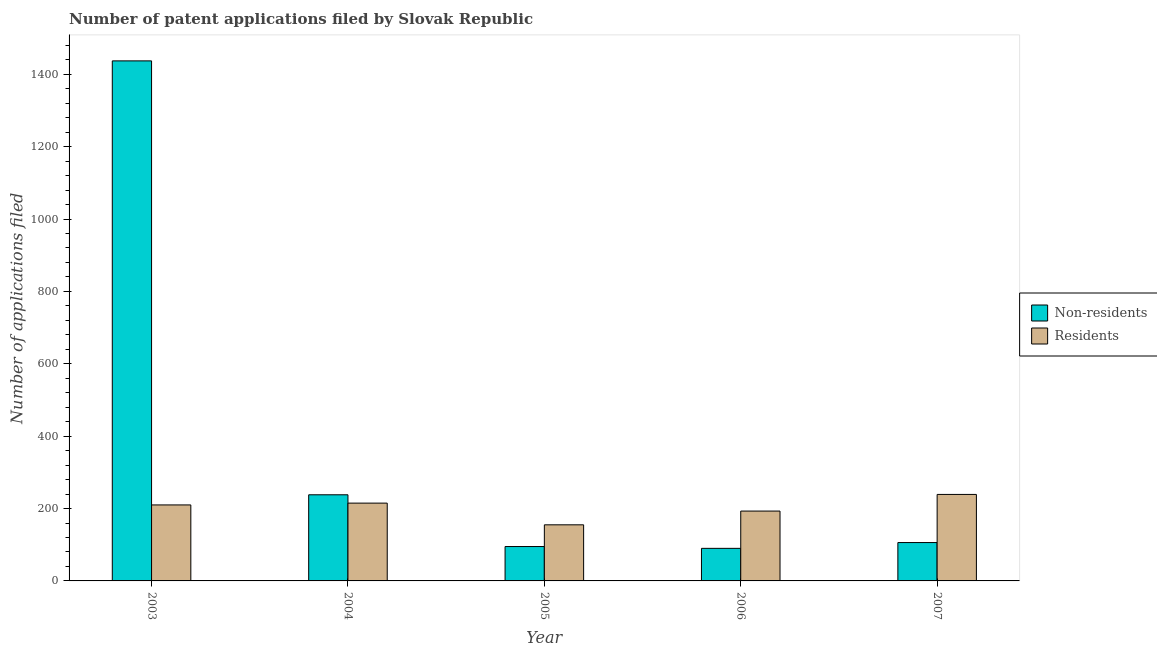How many different coloured bars are there?
Your response must be concise. 2. Are the number of bars per tick equal to the number of legend labels?
Provide a succinct answer. Yes. What is the number of patent applications by residents in 2003?
Ensure brevity in your answer.  210. Across all years, what is the maximum number of patent applications by residents?
Provide a succinct answer. 239. Across all years, what is the minimum number of patent applications by residents?
Offer a very short reply. 155. In which year was the number of patent applications by residents minimum?
Offer a very short reply. 2005. What is the total number of patent applications by non residents in the graph?
Your response must be concise. 1966. What is the difference between the number of patent applications by non residents in 2003 and that in 2006?
Keep it short and to the point. 1347. What is the difference between the number of patent applications by residents in 2004 and the number of patent applications by non residents in 2007?
Keep it short and to the point. -24. What is the average number of patent applications by residents per year?
Offer a terse response. 202.4. In the year 2006, what is the difference between the number of patent applications by non residents and number of patent applications by residents?
Ensure brevity in your answer.  0. In how many years, is the number of patent applications by residents greater than 1120?
Keep it short and to the point. 0. What is the ratio of the number of patent applications by residents in 2003 to that in 2005?
Offer a terse response. 1.35. Is the number of patent applications by non residents in 2006 less than that in 2007?
Keep it short and to the point. Yes. What is the difference between the highest and the second highest number of patent applications by residents?
Give a very brief answer. 24. What is the difference between the highest and the lowest number of patent applications by residents?
Your answer should be very brief. 84. In how many years, is the number of patent applications by residents greater than the average number of patent applications by residents taken over all years?
Your response must be concise. 3. What does the 2nd bar from the left in 2004 represents?
Your response must be concise. Residents. What does the 1st bar from the right in 2003 represents?
Your response must be concise. Residents. How many bars are there?
Offer a terse response. 10. Are all the bars in the graph horizontal?
Your answer should be compact. No. How many years are there in the graph?
Your answer should be very brief. 5. Are the values on the major ticks of Y-axis written in scientific E-notation?
Provide a short and direct response. No. How many legend labels are there?
Your response must be concise. 2. What is the title of the graph?
Keep it short and to the point. Number of patent applications filed by Slovak Republic. Does "Highest 20% of population" appear as one of the legend labels in the graph?
Your answer should be very brief. No. What is the label or title of the X-axis?
Give a very brief answer. Year. What is the label or title of the Y-axis?
Provide a short and direct response. Number of applications filed. What is the Number of applications filed in Non-residents in 2003?
Provide a succinct answer. 1437. What is the Number of applications filed of Residents in 2003?
Offer a terse response. 210. What is the Number of applications filed in Non-residents in 2004?
Offer a terse response. 238. What is the Number of applications filed in Residents in 2004?
Provide a short and direct response. 215. What is the Number of applications filed of Non-residents in 2005?
Keep it short and to the point. 95. What is the Number of applications filed in Residents in 2005?
Your response must be concise. 155. What is the Number of applications filed of Non-residents in 2006?
Your answer should be very brief. 90. What is the Number of applications filed of Residents in 2006?
Provide a short and direct response. 193. What is the Number of applications filed in Non-residents in 2007?
Offer a terse response. 106. What is the Number of applications filed in Residents in 2007?
Keep it short and to the point. 239. Across all years, what is the maximum Number of applications filed in Non-residents?
Your answer should be compact. 1437. Across all years, what is the maximum Number of applications filed of Residents?
Your response must be concise. 239. Across all years, what is the minimum Number of applications filed in Non-residents?
Provide a succinct answer. 90. Across all years, what is the minimum Number of applications filed of Residents?
Give a very brief answer. 155. What is the total Number of applications filed of Non-residents in the graph?
Give a very brief answer. 1966. What is the total Number of applications filed of Residents in the graph?
Give a very brief answer. 1012. What is the difference between the Number of applications filed in Non-residents in 2003 and that in 2004?
Provide a short and direct response. 1199. What is the difference between the Number of applications filed of Non-residents in 2003 and that in 2005?
Make the answer very short. 1342. What is the difference between the Number of applications filed in Residents in 2003 and that in 2005?
Your answer should be very brief. 55. What is the difference between the Number of applications filed in Non-residents in 2003 and that in 2006?
Offer a very short reply. 1347. What is the difference between the Number of applications filed in Residents in 2003 and that in 2006?
Your answer should be compact. 17. What is the difference between the Number of applications filed in Non-residents in 2003 and that in 2007?
Provide a short and direct response. 1331. What is the difference between the Number of applications filed in Non-residents in 2004 and that in 2005?
Keep it short and to the point. 143. What is the difference between the Number of applications filed in Residents in 2004 and that in 2005?
Give a very brief answer. 60. What is the difference between the Number of applications filed in Non-residents in 2004 and that in 2006?
Keep it short and to the point. 148. What is the difference between the Number of applications filed in Residents in 2004 and that in 2006?
Keep it short and to the point. 22. What is the difference between the Number of applications filed in Non-residents in 2004 and that in 2007?
Your answer should be compact. 132. What is the difference between the Number of applications filed of Residents in 2004 and that in 2007?
Offer a very short reply. -24. What is the difference between the Number of applications filed in Non-residents in 2005 and that in 2006?
Offer a very short reply. 5. What is the difference between the Number of applications filed in Residents in 2005 and that in 2006?
Ensure brevity in your answer.  -38. What is the difference between the Number of applications filed of Residents in 2005 and that in 2007?
Offer a very short reply. -84. What is the difference between the Number of applications filed of Residents in 2006 and that in 2007?
Your response must be concise. -46. What is the difference between the Number of applications filed of Non-residents in 2003 and the Number of applications filed of Residents in 2004?
Make the answer very short. 1222. What is the difference between the Number of applications filed in Non-residents in 2003 and the Number of applications filed in Residents in 2005?
Give a very brief answer. 1282. What is the difference between the Number of applications filed in Non-residents in 2003 and the Number of applications filed in Residents in 2006?
Your answer should be compact. 1244. What is the difference between the Number of applications filed of Non-residents in 2003 and the Number of applications filed of Residents in 2007?
Your answer should be compact. 1198. What is the difference between the Number of applications filed of Non-residents in 2004 and the Number of applications filed of Residents in 2005?
Provide a succinct answer. 83. What is the difference between the Number of applications filed in Non-residents in 2005 and the Number of applications filed in Residents in 2006?
Offer a very short reply. -98. What is the difference between the Number of applications filed in Non-residents in 2005 and the Number of applications filed in Residents in 2007?
Ensure brevity in your answer.  -144. What is the difference between the Number of applications filed of Non-residents in 2006 and the Number of applications filed of Residents in 2007?
Keep it short and to the point. -149. What is the average Number of applications filed in Non-residents per year?
Your answer should be compact. 393.2. What is the average Number of applications filed of Residents per year?
Provide a short and direct response. 202.4. In the year 2003, what is the difference between the Number of applications filed in Non-residents and Number of applications filed in Residents?
Ensure brevity in your answer.  1227. In the year 2004, what is the difference between the Number of applications filed in Non-residents and Number of applications filed in Residents?
Provide a succinct answer. 23. In the year 2005, what is the difference between the Number of applications filed of Non-residents and Number of applications filed of Residents?
Your response must be concise. -60. In the year 2006, what is the difference between the Number of applications filed in Non-residents and Number of applications filed in Residents?
Give a very brief answer. -103. In the year 2007, what is the difference between the Number of applications filed of Non-residents and Number of applications filed of Residents?
Your answer should be compact. -133. What is the ratio of the Number of applications filed in Non-residents in 2003 to that in 2004?
Provide a succinct answer. 6.04. What is the ratio of the Number of applications filed of Residents in 2003 to that in 2004?
Make the answer very short. 0.98. What is the ratio of the Number of applications filed in Non-residents in 2003 to that in 2005?
Your answer should be very brief. 15.13. What is the ratio of the Number of applications filed in Residents in 2003 to that in 2005?
Make the answer very short. 1.35. What is the ratio of the Number of applications filed in Non-residents in 2003 to that in 2006?
Your answer should be very brief. 15.97. What is the ratio of the Number of applications filed in Residents in 2003 to that in 2006?
Offer a very short reply. 1.09. What is the ratio of the Number of applications filed in Non-residents in 2003 to that in 2007?
Offer a very short reply. 13.56. What is the ratio of the Number of applications filed in Residents in 2003 to that in 2007?
Make the answer very short. 0.88. What is the ratio of the Number of applications filed of Non-residents in 2004 to that in 2005?
Offer a very short reply. 2.51. What is the ratio of the Number of applications filed of Residents in 2004 to that in 2005?
Provide a succinct answer. 1.39. What is the ratio of the Number of applications filed in Non-residents in 2004 to that in 2006?
Offer a terse response. 2.64. What is the ratio of the Number of applications filed of Residents in 2004 to that in 2006?
Ensure brevity in your answer.  1.11. What is the ratio of the Number of applications filed of Non-residents in 2004 to that in 2007?
Provide a succinct answer. 2.25. What is the ratio of the Number of applications filed of Residents in 2004 to that in 2007?
Offer a terse response. 0.9. What is the ratio of the Number of applications filed in Non-residents in 2005 to that in 2006?
Offer a very short reply. 1.06. What is the ratio of the Number of applications filed in Residents in 2005 to that in 2006?
Offer a very short reply. 0.8. What is the ratio of the Number of applications filed in Non-residents in 2005 to that in 2007?
Offer a very short reply. 0.9. What is the ratio of the Number of applications filed of Residents in 2005 to that in 2007?
Your response must be concise. 0.65. What is the ratio of the Number of applications filed in Non-residents in 2006 to that in 2007?
Your answer should be compact. 0.85. What is the ratio of the Number of applications filed in Residents in 2006 to that in 2007?
Provide a succinct answer. 0.81. What is the difference between the highest and the second highest Number of applications filed in Non-residents?
Keep it short and to the point. 1199. What is the difference between the highest and the lowest Number of applications filed in Non-residents?
Give a very brief answer. 1347. What is the difference between the highest and the lowest Number of applications filed of Residents?
Your response must be concise. 84. 